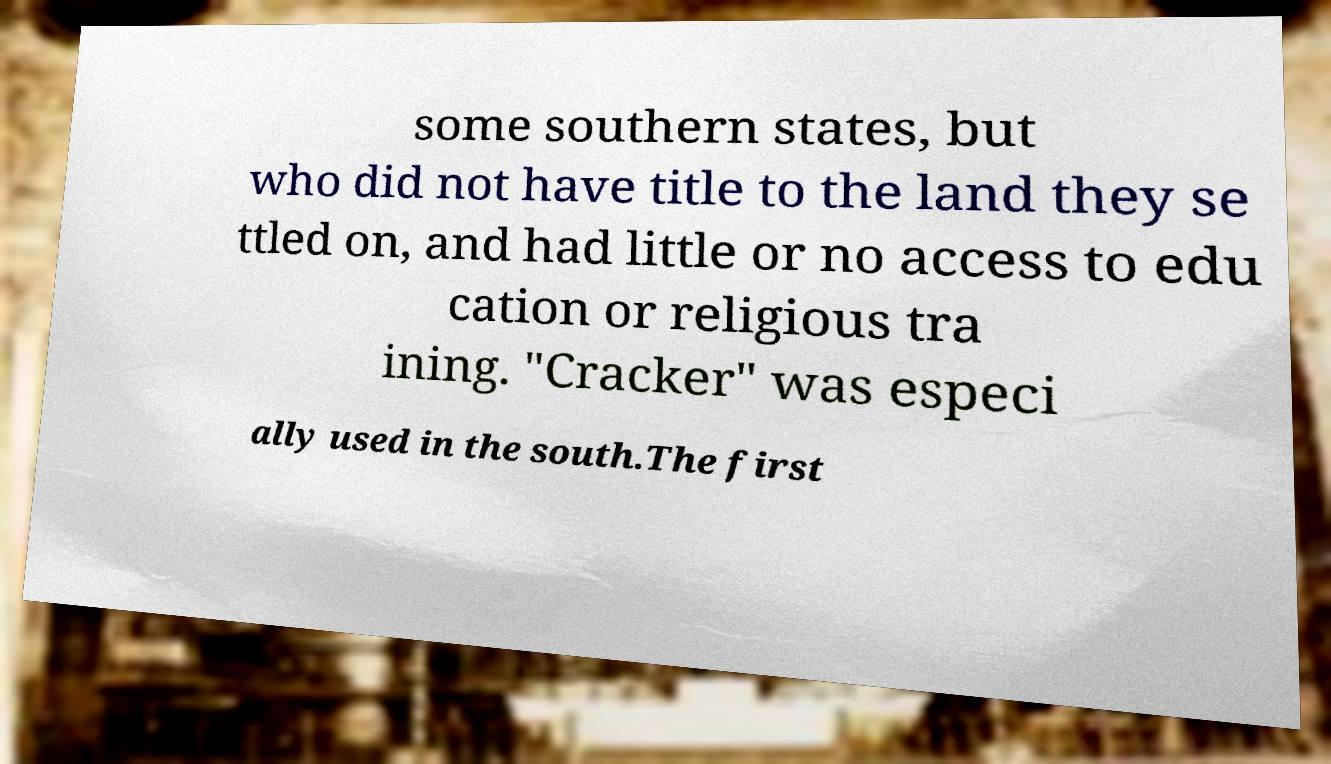Can you accurately transcribe the text from the provided image for me? some southern states, but who did not have title to the land they se ttled on, and had little or no access to edu cation or religious tra ining. "Cracker" was especi ally used in the south.The first 